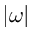<formula> <loc_0><loc_0><loc_500><loc_500>| \omega |</formula> 